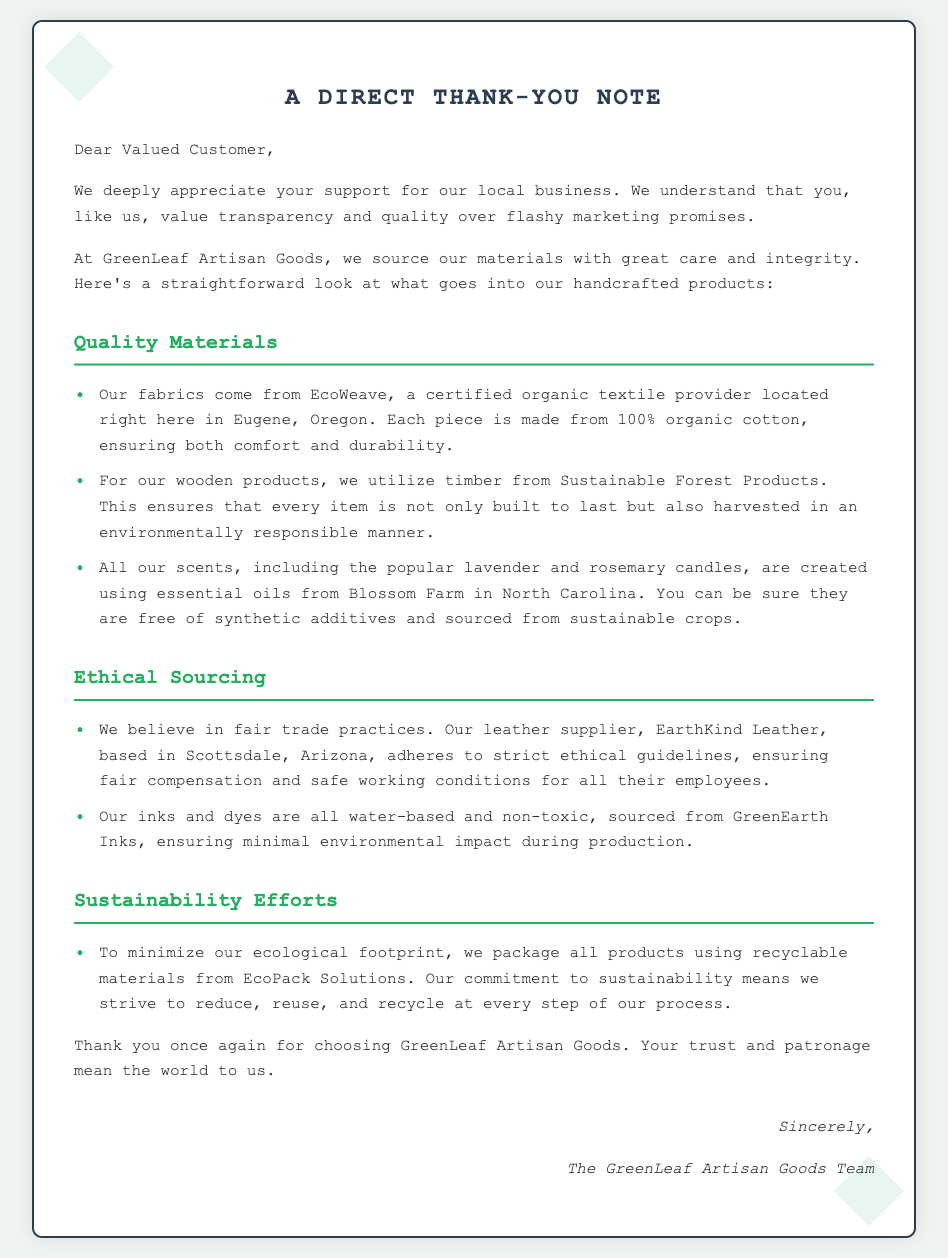What is the source of the fabrics used? The document states that fabrics come from EcoWeave, a certified organic textile provider.
Answer: EcoWeave What type of cotton is used in the products? The document mentions that the fabrics are made from 100% organic cotton.
Answer: 100% organic cotton Where is the leather supplier located? The document specifies that the leather supplier, EarthKind Leather, is based in Scottsdale, Arizona.
Answer: Scottsdale, Arizona What is used to create the scents in the candles? The document states that scents are created using essential oils from Blossom Farm.
Answer: Essential oils What is the company's approach to packaging? The document notes that all products are packaged using recyclable materials from EcoPack Solutions.
Answer: Recyclable materials What is the commitment made by GreenLeaf Artisan Goods regarding environmental impact? The document mentions a commitment to reduce, reuse, and recycle at every step of the process.
Answer: Reduce, reuse, and recycle What color is used for headings in the document? The document describes the color of headings as being a shade of green.
Answer: Green What does the card thank customers for? The document expresses appreciation for the customers' trust and patronage.
Answer: Trust and patronage What type of business is GreenLeaf Artisan Goods? The document indicates that it is a local business that emphasizes quality and transparency.
Answer: Local business 